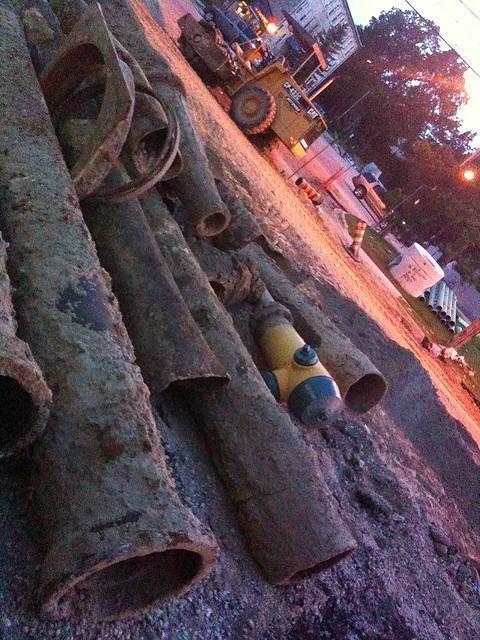What type of site is this?
Indicate the correct choice and explain in the format: 'Answer: answer
Rationale: rationale.'
Options: Burial, historical, religious, construction. Answer: construction.
Rationale: There is an industrial vehicle, a lot of mud and large underground pipes in a pile. 